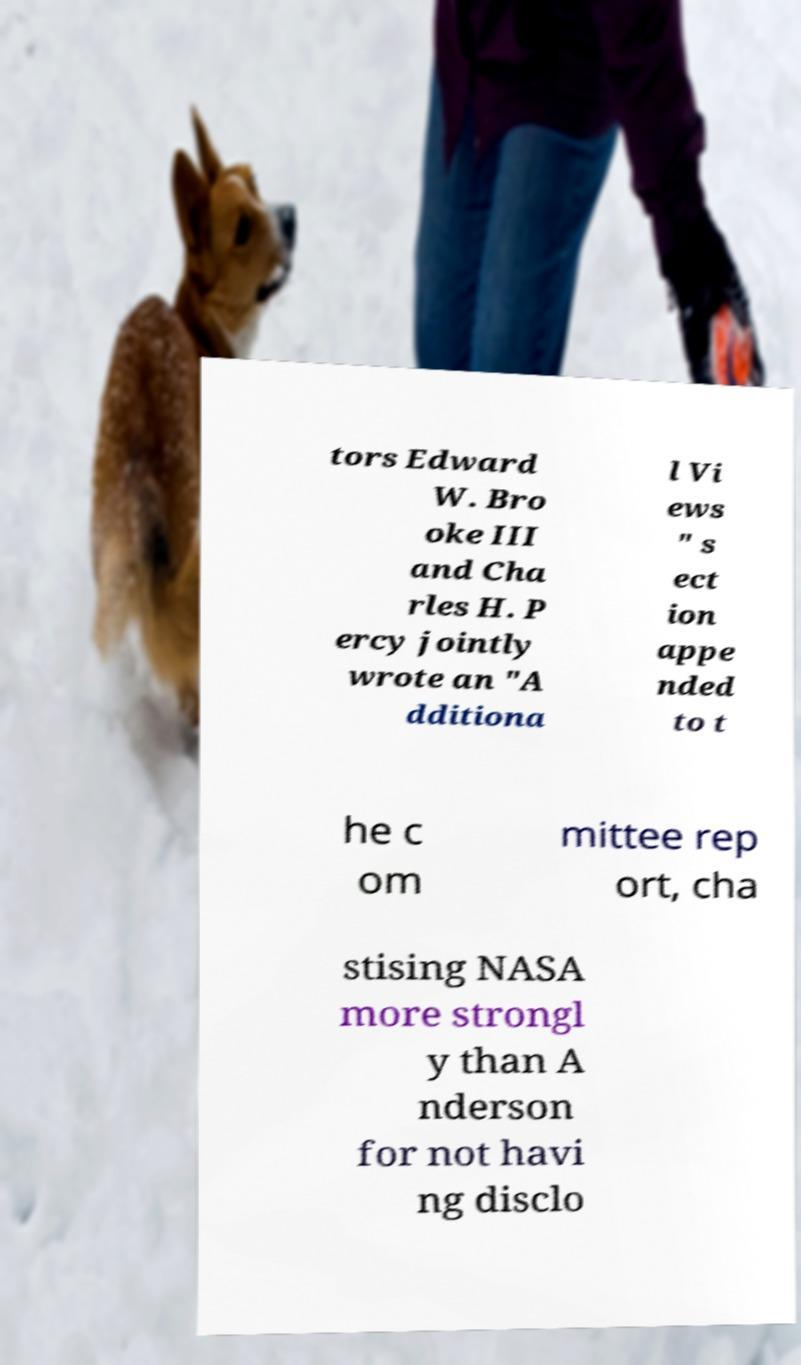There's text embedded in this image that I need extracted. Can you transcribe it verbatim? tors Edward W. Bro oke III and Cha rles H. P ercy jointly wrote an "A dditiona l Vi ews " s ect ion appe nded to t he c om mittee rep ort, cha stising NASA more strongl y than A nderson for not havi ng disclo 